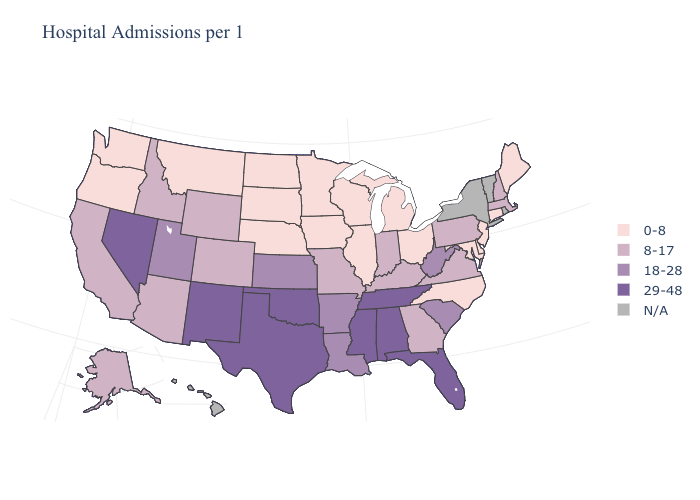Among the states that border Washington , which have the lowest value?
Answer briefly. Oregon. Among the states that border New York , does Pennsylvania have the highest value?
Write a very short answer. Yes. Does Arkansas have the lowest value in the South?
Give a very brief answer. No. Which states have the lowest value in the South?
Answer briefly. Delaware, Maryland, North Carolina. Name the states that have a value in the range N/A?
Short answer required. Hawaii, New York, Rhode Island, Vermont. What is the value of Georgia?
Short answer required. 8-17. Name the states that have a value in the range 0-8?
Keep it brief. Connecticut, Delaware, Illinois, Iowa, Maine, Maryland, Michigan, Minnesota, Montana, Nebraska, New Jersey, North Carolina, North Dakota, Ohio, Oregon, South Dakota, Washington, Wisconsin. Name the states that have a value in the range N/A?
Concise answer only. Hawaii, New York, Rhode Island, Vermont. What is the value of Wyoming?
Keep it brief. 8-17. Among the states that border Mississippi , which have the lowest value?
Concise answer only. Arkansas, Louisiana. Name the states that have a value in the range 18-28?
Give a very brief answer. Arkansas, Kansas, Louisiana, South Carolina, Utah, West Virginia. Name the states that have a value in the range 0-8?
Write a very short answer. Connecticut, Delaware, Illinois, Iowa, Maine, Maryland, Michigan, Minnesota, Montana, Nebraska, New Jersey, North Carolina, North Dakota, Ohio, Oregon, South Dakota, Washington, Wisconsin. What is the highest value in the Northeast ?
Short answer required. 8-17. Does Nevada have the highest value in the USA?
Concise answer only. Yes. Does North Carolina have the lowest value in the USA?
Concise answer only. Yes. 